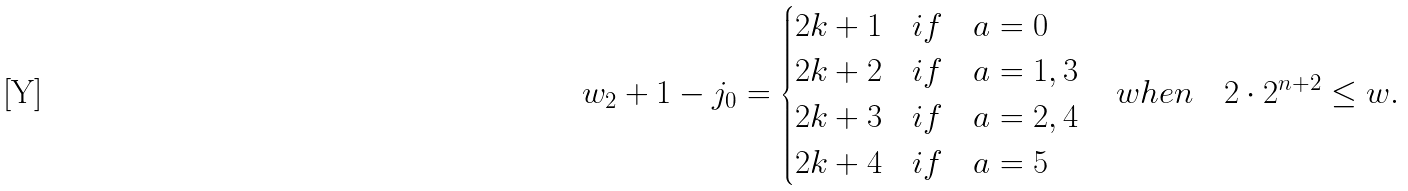<formula> <loc_0><loc_0><loc_500><loc_500>w _ { 2 } + 1 - j _ { 0 } & = \begin{cases} 2 k + 1 & i f \quad a = 0 \\ 2 k + 2 & i f \quad a = 1 , 3 \\ 2 k + 3 & i f \quad a = 2 , 4 \\ 2 k + 4 & i f \quad a = 5 \end{cases} \quad w h e n \quad 2 \cdot 2 ^ { n + 2 } \leq w .</formula> 